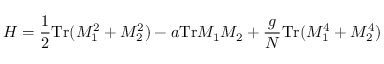<formula> <loc_0><loc_0><loc_500><loc_500>H = { \frac { 1 } { 2 } } T r ( M _ { 1 } ^ { 2 } + M _ { 2 } ^ { 2 } ) - a T r M _ { 1 } M _ { 2 } + { \frac { g } { N } } T r ( M _ { 1 } ^ { 4 } + M _ { 2 } ^ { 4 } )</formula> 